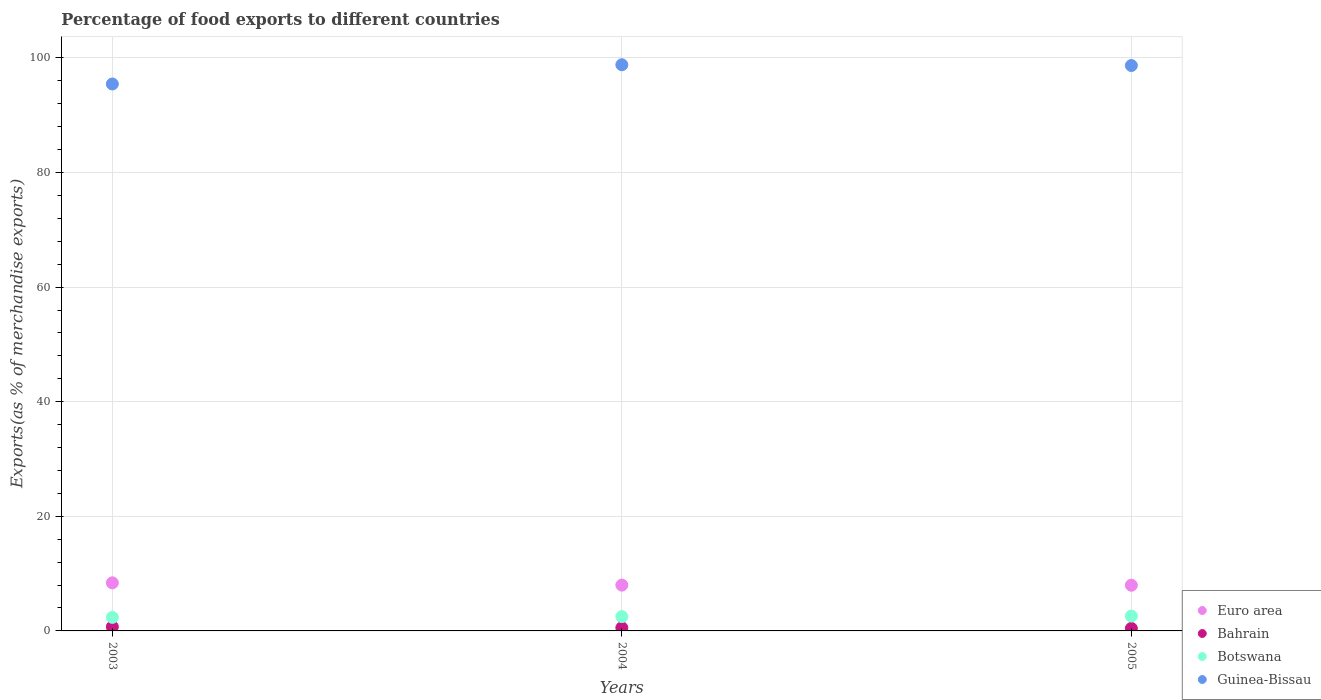How many different coloured dotlines are there?
Provide a short and direct response. 4. Is the number of dotlines equal to the number of legend labels?
Your answer should be very brief. Yes. What is the percentage of exports to different countries in Bahrain in 2003?
Provide a short and direct response. 0.72. Across all years, what is the maximum percentage of exports to different countries in Botswana?
Give a very brief answer. 2.59. Across all years, what is the minimum percentage of exports to different countries in Bahrain?
Ensure brevity in your answer.  0.44. What is the total percentage of exports to different countries in Euro area in the graph?
Your response must be concise. 24.36. What is the difference between the percentage of exports to different countries in Botswana in 2003 and that in 2005?
Provide a succinct answer. -0.23. What is the difference between the percentage of exports to different countries in Euro area in 2004 and the percentage of exports to different countries in Botswana in 2005?
Offer a very short reply. 5.4. What is the average percentage of exports to different countries in Bahrain per year?
Offer a very short reply. 0.57. In the year 2004, what is the difference between the percentage of exports to different countries in Bahrain and percentage of exports to different countries in Guinea-Bissau?
Provide a short and direct response. -98.24. In how many years, is the percentage of exports to different countries in Botswana greater than 84 %?
Offer a terse response. 0. What is the ratio of the percentage of exports to different countries in Guinea-Bissau in 2003 to that in 2005?
Make the answer very short. 0.97. Is the percentage of exports to different countries in Guinea-Bissau in 2003 less than that in 2004?
Give a very brief answer. Yes. What is the difference between the highest and the second highest percentage of exports to different countries in Guinea-Bissau?
Ensure brevity in your answer.  0.13. What is the difference between the highest and the lowest percentage of exports to different countries in Botswana?
Ensure brevity in your answer.  0.23. In how many years, is the percentage of exports to different countries in Bahrain greater than the average percentage of exports to different countries in Bahrain taken over all years?
Offer a very short reply. 1. Is it the case that in every year, the sum of the percentage of exports to different countries in Bahrain and percentage of exports to different countries in Guinea-Bissau  is greater than the percentage of exports to different countries in Euro area?
Your answer should be very brief. Yes. Is the percentage of exports to different countries in Guinea-Bissau strictly less than the percentage of exports to different countries in Bahrain over the years?
Your answer should be very brief. No. How many dotlines are there?
Offer a very short reply. 4. What is the difference between two consecutive major ticks on the Y-axis?
Offer a terse response. 20. Are the values on the major ticks of Y-axis written in scientific E-notation?
Keep it short and to the point. No. Does the graph contain grids?
Offer a terse response. Yes. Where does the legend appear in the graph?
Provide a succinct answer. Bottom right. How many legend labels are there?
Keep it short and to the point. 4. What is the title of the graph?
Give a very brief answer. Percentage of food exports to different countries. What is the label or title of the Y-axis?
Ensure brevity in your answer.  Exports(as % of merchandise exports). What is the Exports(as % of merchandise exports) of Euro area in 2003?
Your answer should be compact. 8.39. What is the Exports(as % of merchandise exports) in Bahrain in 2003?
Provide a succinct answer. 0.72. What is the Exports(as % of merchandise exports) of Botswana in 2003?
Ensure brevity in your answer.  2.36. What is the Exports(as % of merchandise exports) of Guinea-Bissau in 2003?
Give a very brief answer. 95.44. What is the Exports(as % of merchandise exports) in Euro area in 2004?
Offer a very short reply. 7.99. What is the Exports(as % of merchandise exports) in Bahrain in 2004?
Provide a short and direct response. 0.55. What is the Exports(as % of merchandise exports) in Botswana in 2004?
Provide a succinct answer. 2.49. What is the Exports(as % of merchandise exports) of Guinea-Bissau in 2004?
Provide a short and direct response. 98.79. What is the Exports(as % of merchandise exports) of Euro area in 2005?
Your response must be concise. 7.97. What is the Exports(as % of merchandise exports) in Bahrain in 2005?
Give a very brief answer. 0.44. What is the Exports(as % of merchandise exports) in Botswana in 2005?
Your response must be concise. 2.59. What is the Exports(as % of merchandise exports) in Guinea-Bissau in 2005?
Ensure brevity in your answer.  98.66. Across all years, what is the maximum Exports(as % of merchandise exports) in Euro area?
Your answer should be compact. 8.39. Across all years, what is the maximum Exports(as % of merchandise exports) in Bahrain?
Your answer should be very brief. 0.72. Across all years, what is the maximum Exports(as % of merchandise exports) of Botswana?
Your answer should be very brief. 2.59. Across all years, what is the maximum Exports(as % of merchandise exports) in Guinea-Bissau?
Make the answer very short. 98.79. Across all years, what is the minimum Exports(as % of merchandise exports) in Euro area?
Give a very brief answer. 7.97. Across all years, what is the minimum Exports(as % of merchandise exports) in Bahrain?
Make the answer very short. 0.44. Across all years, what is the minimum Exports(as % of merchandise exports) in Botswana?
Keep it short and to the point. 2.36. Across all years, what is the minimum Exports(as % of merchandise exports) in Guinea-Bissau?
Your answer should be compact. 95.44. What is the total Exports(as % of merchandise exports) in Euro area in the graph?
Give a very brief answer. 24.36. What is the total Exports(as % of merchandise exports) in Bahrain in the graph?
Offer a very short reply. 1.7. What is the total Exports(as % of merchandise exports) in Botswana in the graph?
Give a very brief answer. 7.45. What is the total Exports(as % of merchandise exports) in Guinea-Bissau in the graph?
Provide a short and direct response. 292.89. What is the difference between the Exports(as % of merchandise exports) in Bahrain in 2003 and that in 2004?
Give a very brief answer. 0.17. What is the difference between the Exports(as % of merchandise exports) of Botswana in 2003 and that in 2004?
Your answer should be very brief. -0.13. What is the difference between the Exports(as % of merchandise exports) in Guinea-Bissau in 2003 and that in 2004?
Your answer should be compact. -3.36. What is the difference between the Exports(as % of merchandise exports) of Euro area in 2003 and that in 2005?
Make the answer very short. 0.42. What is the difference between the Exports(as % of merchandise exports) in Bahrain in 2003 and that in 2005?
Give a very brief answer. 0.28. What is the difference between the Exports(as % of merchandise exports) in Botswana in 2003 and that in 2005?
Keep it short and to the point. -0.23. What is the difference between the Exports(as % of merchandise exports) of Guinea-Bissau in 2003 and that in 2005?
Give a very brief answer. -3.22. What is the difference between the Exports(as % of merchandise exports) in Euro area in 2004 and that in 2005?
Your response must be concise. 0.02. What is the difference between the Exports(as % of merchandise exports) of Bahrain in 2004 and that in 2005?
Your answer should be compact. 0.11. What is the difference between the Exports(as % of merchandise exports) of Botswana in 2004 and that in 2005?
Your answer should be very brief. -0.1. What is the difference between the Exports(as % of merchandise exports) in Guinea-Bissau in 2004 and that in 2005?
Offer a terse response. 0.13. What is the difference between the Exports(as % of merchandise exports) in Euro area in 2003 and the Exports(as % of merchandise exports) in Bahrain in 2004?
Ensure brevity in your answer.  7.84. What is the difference between the Exports(as % of merchandise exports) in Euro area in 2003 and the Exports(as % of merchandise exports) in Botswana in 2004?
Give a very brief answer. 5.9. What is the difference between the Exports(as % of merchandise exports) in Euro area in 2003 and the Exports(as % of merchandise exports) in Guinea-Bissau in 2004?
Your answer should be compact. -90.4. What is the difference between the Exports(as % of merchandise exports) of Bahrain in 2003 and the Exports(as % of merchandise exports) of Botswana in 2004?
Give a very brief answer. -1.78. What is the difference between the Exports(as % of merchandise exports) of Bahrain in 2003 and the Exports(as % of merchandise exports) of Guinea-Bissau in 2004?
Make the answer very short. -98.08. What is the difference between the Exports(as % of merchandise exports) in Botswana in 2003 and the Exports(as % of merchandise exports) in Guinea-Bissau in 2004?
Your answer should be very brief. -96.43. What is the difference between the Exports(as % of merchandise exports) of Euro area in 2003 and the Exports(as % of merchandise exports) of Bahrain in 2005?
Your answer should be compact. 7.96. What is the difference between the Exports(as % of merchandise exports) in Euro area in 2003 and the Exports(as % of merchandise exports) in Botswana in 2005?
Your answer should be compact. 5.8. What is the difference between the Exports(as % of merchandise exports) of Euro area in 2003 and the Exports(as % of merchandise exports) of Guinea-Bissau in 2005?
Provide a succinct answer. -90.27. What is the difference between the Exports(as % of merchandise exports) in Bahrain in 2003 and the Exports(as % of merchandise exports) in Botswana in 2005?
Make the answer very short. -1.88. What is the difference between the Exports(as % of merchandise exports) in Bahrain in 2003 and the Exports(as % of merchandise exports) in Guinea-Bissau in 2005?
Your answer should be very brief. -97.94. What is the difference between the Exports(as % of merchandise exports) of Botswana in 2003 and the Exports(as % of merchandise exports) of Guinea-Bissau in 2005?
Provide a succinct answer. -96.3. What is the difference between the Exports(as % of merchandise exports) of Euro area in 2004 and the Exports(as % of merchandise exports) of Bahrain in 2005?
Your answer should be very brief. 7.56. What is the difference between the Exports(as % of merchandise exports) in Euro area in 2004 and the Exports(as % of merchandise exports) in Botswana in 2005?
Ensure brevity in your answer.  5.4. What is the difference between the Exports(as % of merchandise exports) in Euro area in 2004 and the Exports(as % of merchandise exports) in Guinea-Bissau in 2005?
Make the answer very short. -90.67. What is the difference between the Exports(as % of merchandise exports) in Bahrain in 2004 and the Exports(as % of merchandise exports) in Botswana in 2005?
Give a very brief answer. -2.04. What is the difference between the Exports(as % of merchandise exports) in Bahrain in 2004 and the Exports(as % of merchandise exports) in Guinea-Bissau in 2005?
Your response must be concise. -98.11. What is the difference between the Exports(as % of merchandise exports) in Botswana in 2004 and the Exports(as % of merchandise exports) in Guinea-Bissau in 2005?
Ensure brevity in your answer.  -96.17. What is the average Exports(as % of merchandise exports) of Euro area per year?
Your answer should be compact. 8.12. What is the average Exports(as % of merchandise exports) in Bahrain per year?
Provide a short and direct response. 0.57. What is the average Exports(as % of merchandise exports) in Botswana per year?
Make the answer very short. 2.48. What is the average Exports(as % of merchandise exports) in Guinea-Bissau per year?
Keep it short and to the point. 97.63. In the year 2003, what is the difference between the Exports(as % of merchandise exports) in Euro area and Exports(as % of merchandise exports) in Bahrain?
Your answer should be compact. 7.68. In the year 2003, what is the difference between the Exports(as % of merchandise exports) in Euro area and Exports(as % of merchandise exports) in Botswana?
Make the answer very short. 6.03. In the year 2003, what is the difference between the Exports(as % of merchandise exports) of Euro area and Exports(as % of merchandise exports) of Guinea-Bissau?
Provide a succinct answer. -87.05. In the year 2003, what is the difference between the Exports(as % of merchandise exports) in Bahrain and Exports(as % of merchandise exports) in Botswana?
Your response must be concise. -1.65. In the year 2003, what is the difference between the Exports(as % of merchandise exports) of Bahrain and Exports(as % of merchandise exports) of Guinea-Bissau?
Your answer should be compact. -94.72. In the year 2003, what is the difference between the Exports(as % of merchandise exports) in Botswana and Exports(as % of merchandise exports) in Guinea-Bissau?
Ensure brevity in your answer.  -93.07. In the year 2004, what is the difference between the Exports(as % of merchandise exports) of Euro area and Exports(as % of merchandise exports) of Bahrain?
Your answer should be very brief. 7.44. In the year 2004, what is the difference between the Exports(as % of merchandise exports) in Euro area and Exports(as % of merchandise exports) in Botswana?
Make the answer very short. 5.5. In the year 2004, what is the difference between the Exports(as % of merchandise exports) of Euro area and Exports(as % of merchandise exports) of Guinea-Bissau?
Give a very brief answer. -90.8. In the year 2004, what is the difference between the Exports(as % of merchandise exports) in Bahrain and Exports(as % of merchandise exports) in Botswana?
Your response must be concise. -1.94. In the year 2004, what is the difference between the Exports(as % of merchandise exports) in Bahrain and Exports(as % of merchandise exports) in Guinea-Bissau?
Provide a succinct answer. -98.24. In the year 2004, what is the difference between the Exports(as % of merchandise exports) of Botswana and Exports(as % of merchandise exports) of Guinea-Bissau?
Your answer should be compact. -96.3. In the year 2005, what is the difference between the Exports(as % of merchandise exports) in Euro area and Exports(as % of merchandise exports) in Bahrain?
Provide a short and direct response. 7.54. In the year 2005, what is the difference between the Exports(as % of merchandise exports) of Euro area and Exports(as % of merchandise exports) of Botswana?
Your answer should be compact. 5.38. In the year 2005, what is the difference between the Exports(as % of merchandise exports) of Euro area and Exports(as % of merchandise exports) of Guinea-Bissau?
Ensure brevity in your answer.  -90.69. In the year 2005, what is the difference between the Exports(as % of merchandise exports) in Bahrain and Exports(as % of merchandise exports) in Botswana?
Keep it short and to the point. -2.15. In the year 2005, what is the difference between the Exports(as % of merchandise exports) in Bahrain and Exports(as % of merchandise exports) in Guinea-Bissau?
Offer a very short reply. -98.22. In the year 2005, what is the difference between the Exports(as % of merchandise exports) in Botswana and Exports(as % of merchandise exports) in Guinea-Bissau?
Make the answer very short. -96.07. What is the ratio of the Exports(as % of merchandise exports) in Euro area in 2003 to that in 2004?
Keep it short and to the point. 1.05. What is the ratio of the Exports(as % of merchandise exports) in Bahrain in 2003 to that in 2004?
Offer a terse response. 1.3. What is the ratio of the Exports(as % of merchandise exports) in Botswana in 2003 to that in 2004?
Offer a terse response. 0.95. What is the ratio of the Exports(as % of merchandise exports) of Euro area in 2003 to that in 2005?
Give a very brief answer. 1.05. What is the ratio of the Exports(as % of merchandise exports) in Bahrain in 2003 to that in 2005?
Provide a short and direct response. 1.64. What is the ratio of the Exports(as % of merchandise exports) of Botswana in 2003 to that in 2005?
Ensure brevity in your answer.  0.91. What is the ratio of the Exports(as % of merchandise exports) of Guinea-Bissau in 2003 to that in 2005?
Your answer should be compact. 0.97. What is the ratio of the Exports(as % of merchandise exports) in Euro area in 2004 to that in 2005?
Keep it short and to the point. 1. What is the ratio of the Exports(as % of merchandise exports) in Bahrain in 2004 to that in 2005?
Offer a terse response. 1.26. What is the ratio of the Exports(as % of merchandise exports) of Botswana in 2004 to that in 2005?
Keep it short and to the point. 0.96. What is the difference between the highest and the second highest Exports(as % of merchandise exports) in Bahrain?
Keep it short and to the point. 0.17. What is the difference between the highest and the second highest Exports(as % of merchandise exports) in Botswana?
Your answer should be very brief. 0.1. What is the difference between the highest and the second highest Exports(as % of merchandise exports) of Guinea-Bissau?
Offer a very short reply. 0.13. What is the difference between the highest and the lowest Exports(as % of merchandise exports) in Euro area?
Your response must be concise. 0.42. What is the difference between the highest and the lowest Exports(as % of merchandise exports) of Bahrain?
Your response must be concise. 0.28. What is the difference between the highest and the lowest Exports(as % of merchandise exports) in Botswana?
Give a very brief answer. 0.23. What is the difference between the highest and the lowest Exports(as % of merchandise exports) in Guinea-Bissau?
Your answer should be very brief. 3.36. 